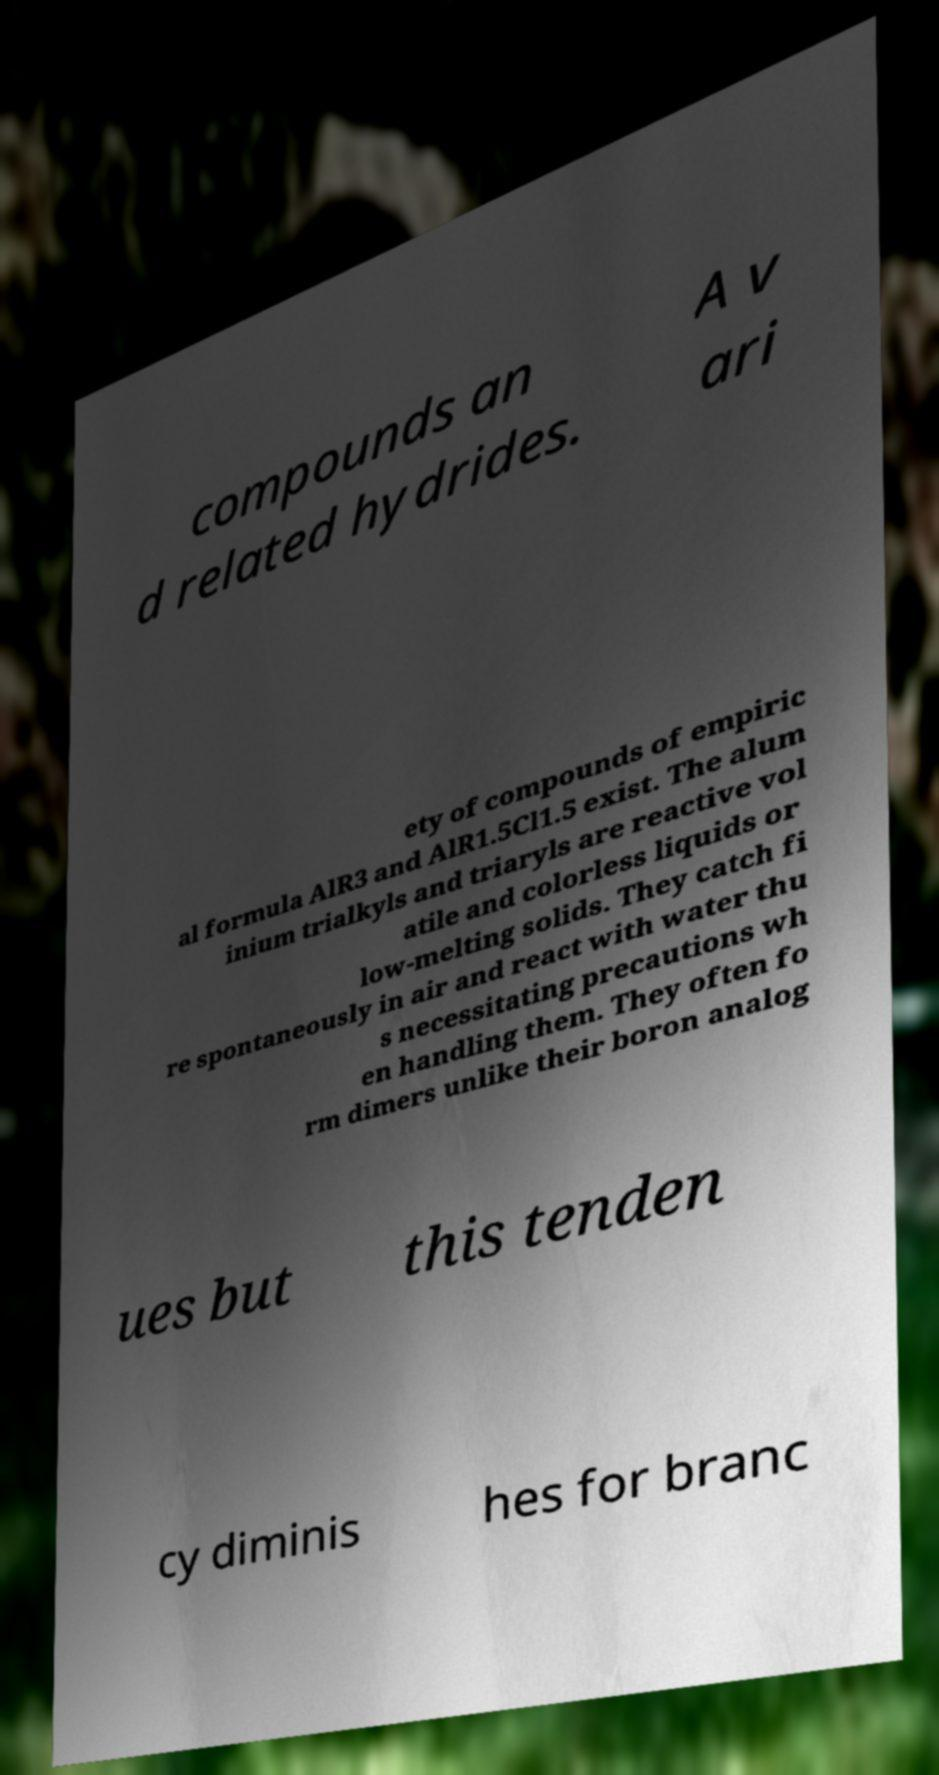Can you accurately transcribe the text from the provided image for me? compounds an d related hydrides. A v ari ety of compounds of empiric al formula AlR3 and AlR1.5Cl1.5 exist. The alum inium trialkyls and triaryls are reactive vol atile and colorless liquids or low-melting solids. They catch fi re spontaneously in air and react with water thu s necessitating precautions wh en handling them. They often fo rm dimers unlike their boron analog ues but this tenden cy diminis hes for branc 